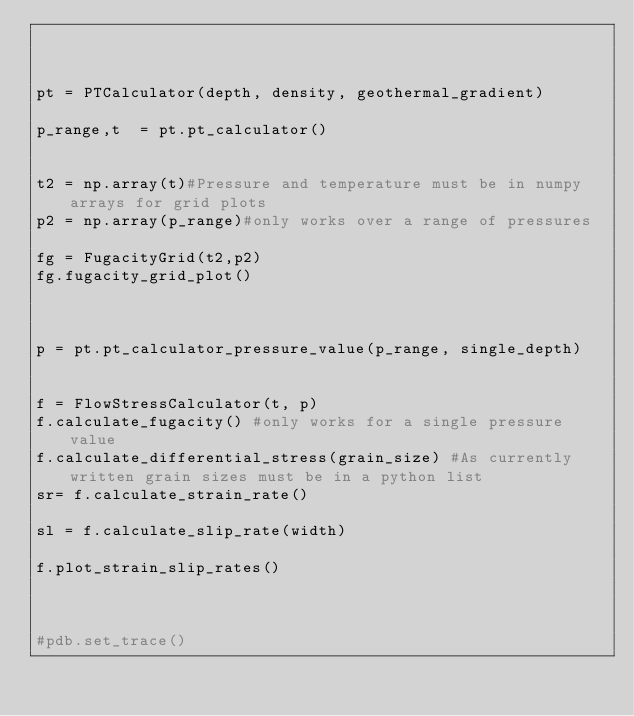<code> <loc_0><loc_0><loc_500><loc_500><_Python_>


pt = PTCalculator(depth, density, geothermal_gradient)

p_range,t  = pt.pt_calculator()


t2 = np.array(t)#Pressure and temperature must be in numpy arrays for grid plots
p2 = np.array(p_range)#only works over a range of pressures

fg = FugacityGrid(t2,p2)
fg.fugacity_grid_plot()



p = pt.pt_calculator_pressure_value(p_range, single_depth) 


f = FlowStressCalculator(t, p)
f.calculate_fugacity() #only works for a single pressure value
f.calculate_differential_stress(grain_size) #As currently written grain sizes must be in a python list
sr= f.calculate_strain_rate()

sl = f.calculate_slip_rate(width)

f.plot_strain_slip_rates()



#pdb.set_trace()




</code> 